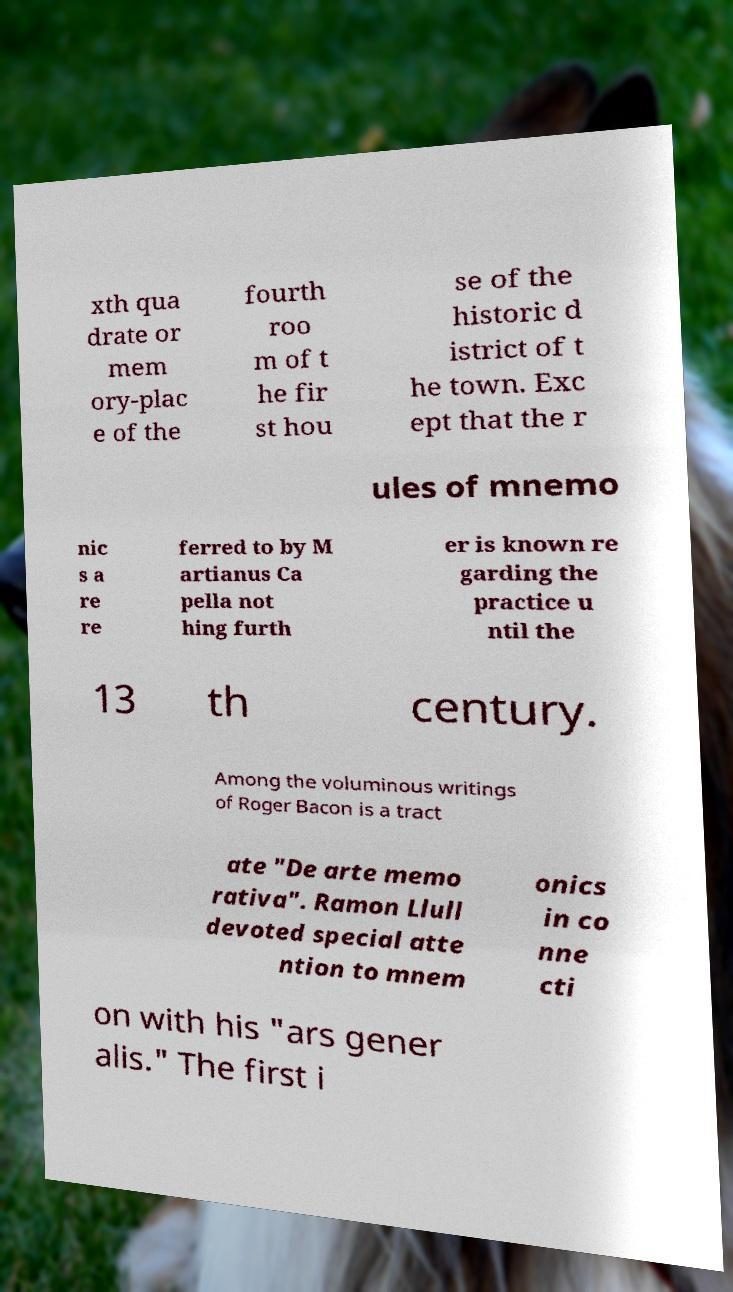Can you read and provide the text displayed in the image?This photo seems to have some interesting text. Can you extract and type it out for me? xth qua drate or mem ory-plac e of the fourth roo m of t he fir st hou se of the historic d istrict of t he town. Exc ept that the r ules of mnemo nic s a re re ferred to by M artianus Ca pella not hing furth er is known re garding the practice u ntil the 13 th century. Among the voluminous writings of Roger Bacon is a tract ate "De arte memo rativa". Ramon Llull devoted special atte ntion to mnem onics in co nne cti on with his "ars gener alis." The first i 